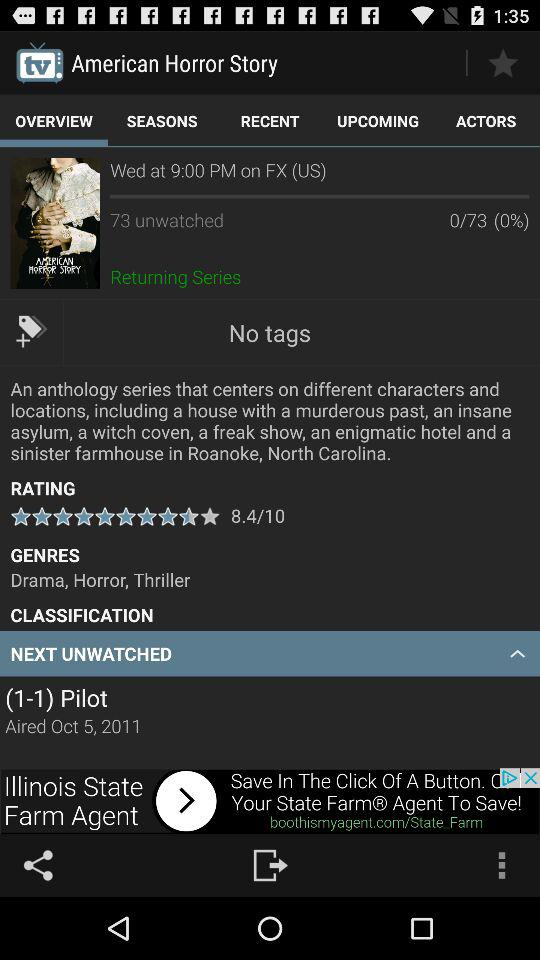On what channel was the movie "American Horror Story" aired? The movie was aired on the channel "FX". 